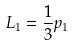<formula> <loc_0><loc_0><loc_500><loc_500>L _ { 1 } = \frac { 1 } { 3 } p _ { 1 }</formula> 